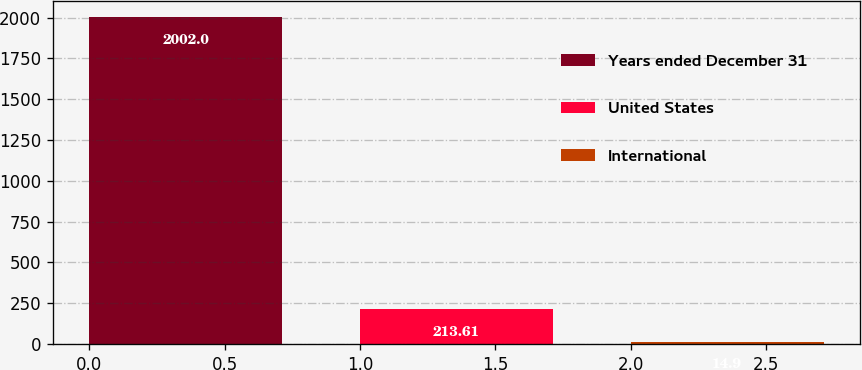Convert chart to OTSL. <chart><loc_0><loc_0><loc_500><loc_500><bar_chart><fcel>Years ended December 31<fcel>United States<fcel>International<nl><fcel>2002<fcel>213.61<fcel>14.9<nl></chart> 